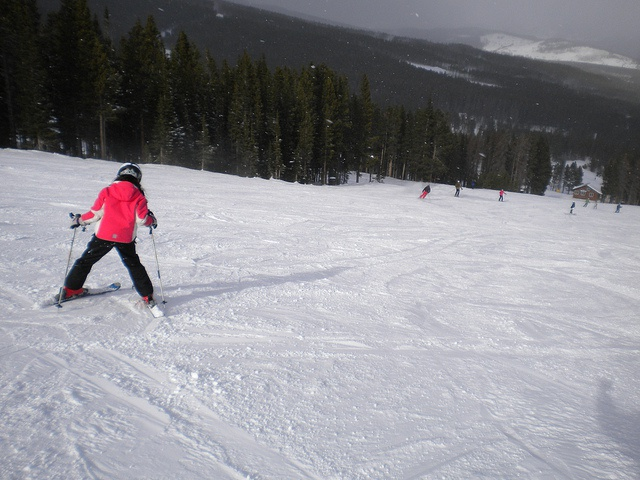Describe the objects in this image and their specific colors. I can see people in black, red, darkgray, and lightgray tones, skis in black, darkgray, gray, and lightgray tones, people in black, gray, darkgray, and lightgray tones, people in black, gray, brown, and darkgray tones, and people in black, darkgray, brown, and gray tones in this image. 